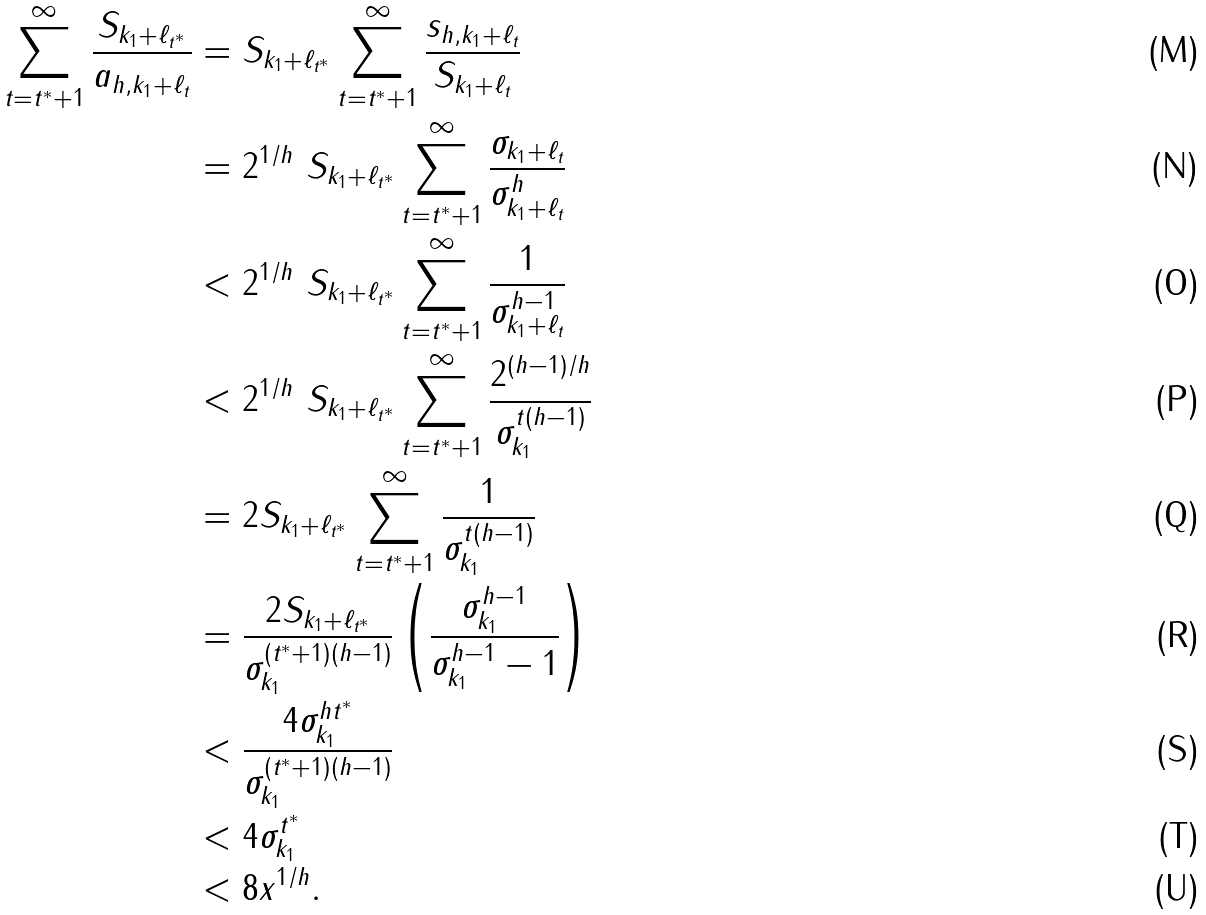<formula> <loc_0><loc_0><loc_500><loc_500>\sum _ { t = t ^ { * } + 1 } ^ { \infty } \frac { S _ { k _ { 1 } + \ell _ { t ^ { * } } } } { a _ { h , { k _ { 1 } } + \ell _ { t } } } & = S _ { k _ { 1 } + \ell _ { t ^ { * } } } \sum _ { t = t ^ { * } + 1 } ^ { \infty } \frac { s _ { h , k _ { 1 } + \ell _ { t } } } { S _ { k _ { 1 } + \ell _ { t } } } \\ & = 2 ^ { 1 / h } \ S _ { k _ { 1 } + \ell _ { t ^ { * } } } \sum _ { t = t ^ { * } + 1 } ^ { \infty } \frac { \sigma _ { k _ { 1 } + \ell _ { t } } } { \sigma _ { k _ { 1 } + \ell _ { t } } ^ { h } } \\ & < 2 ^ { 1 / h } \ S _ { k _ { 1 } + \ell _ { t ^ { * } } } \sum _ { t = t ^ { * } + 1 } ^ { \infty } \frac { 1 } { \sigma _ { k _ { 1 } + \ell _ { t } } ^ { h - 1 } } \\ & < 2 ^ { 1 / h } \ S _ { k _ { 1 } + \ell _ { t ^ { * } } } \sum _ { t = t ^ { * } + 1 } ^ { \infty } \frac { 2 ^ { ( h - 1 ) / h } } { \sigma _ { k _ { 1 } } ^ { t ( h - 1 ) } } \\ & = 2 S _ { k _ { 1 } + \ell _ { t ^ { * } } } \sum _ { t = t ^ { * } + 1 } ^ { \infty } \frac { 1 } { \sigma _ { k _ { 1 } } ^ { t ( h - 1 ) } } \\ & = \frac { 2 S _ { k _ { 1 } + \ell _ { t ^ { * } } } } { \sigma _ { k _ { 1 } } ^ { ( t ^ { * } + 1 ) ( h - 1 ) } } \left ( \frac { \sigma _ { k _ { 1 } } ^ { h - 1 } } { \sigma _ { k _ { 1 } } ^ { h - 1 } - 1 } \right ) \\ & < \frac { 4 \sigma _ { k _ { 1 } } ^ { h t ^ { * } } } { \sigma _ { k _ { 1 } } ^ { ( t ^ { * } + 1 ) ( h - 1 ) } } \\ & < 4 \sigma _ { k _ { 1 } } ^ { t ^ { * } } \\ & < 8 x ^ { 1 / h } .</formula> 